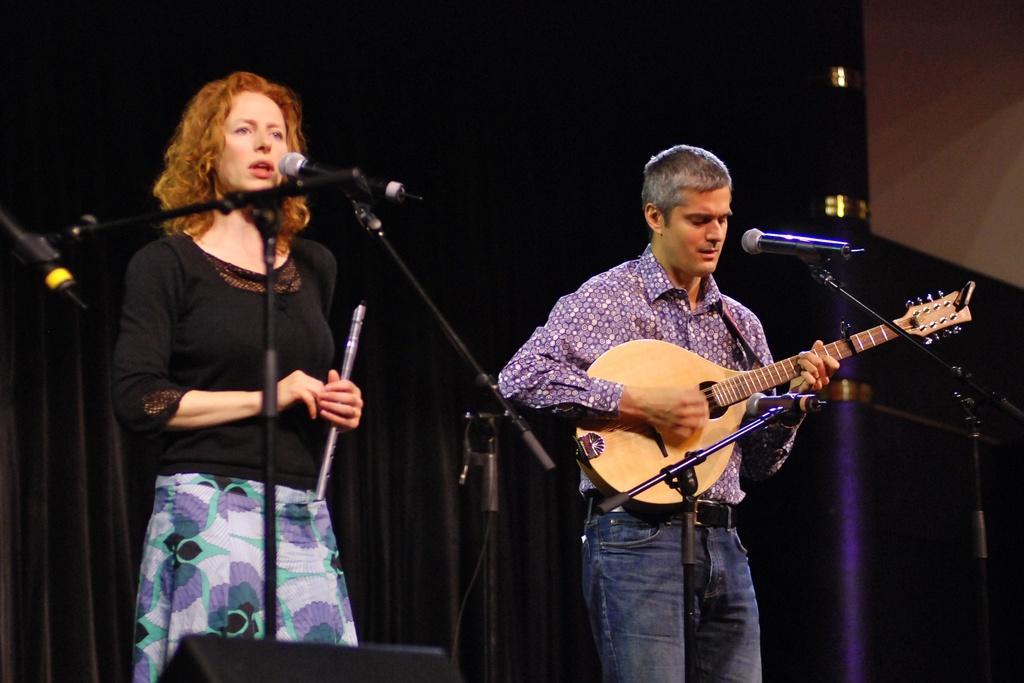Can you describe this image briefly? This picture shows that there are two members standing on the stage. Man is holding a guitar in his hand. In front of him there is a microphone and a stand here. The woman is singing. She is holding a flute in her hands. She is also having a microphone and stand in front of her. 